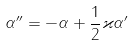<formula> <loc_0><loc_0><loc_500><loc_500>\alpha ^ { \prime \prime } = - \alpha + \frac { 1 } { 2 } \varkappa \alpha ^ { \prime }</formula> 